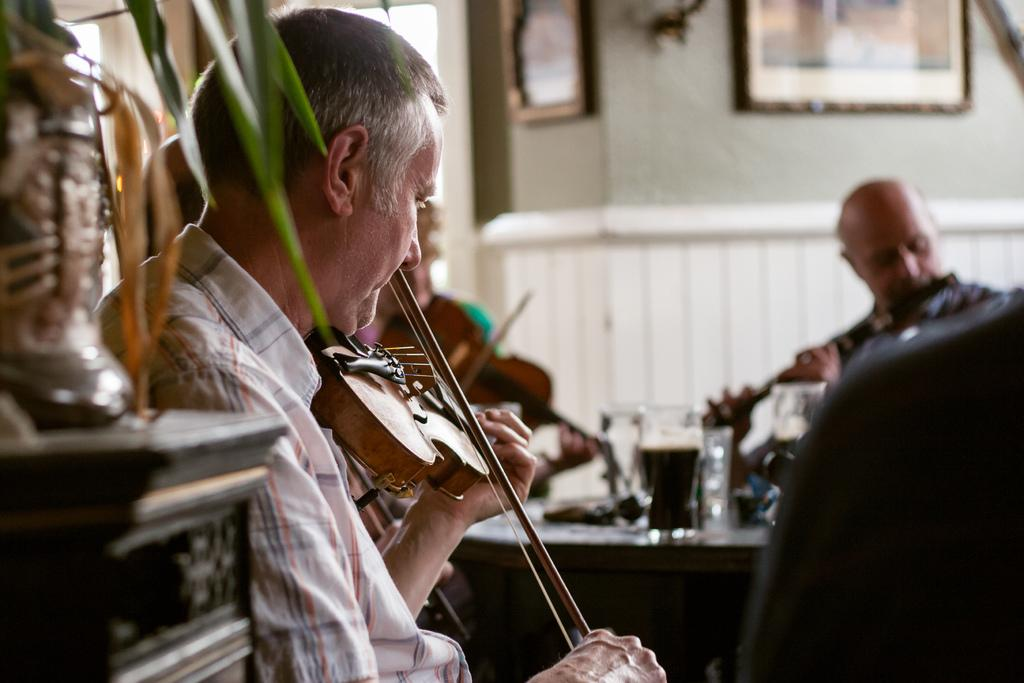What is the person in the image doing? The person is playing the violin. What is the person sitting on or near in the image? There is a table in the image. What can be seen on the table? There are glasses and other objects on the table. What is present on the wall in the image? There are photo frames on the wall. Can you see the person's mother playing the piano in the image? There is no mention of a piano or the person's mother in the image. Are there any trees visible in the image? There is no mention of trees in the image. 